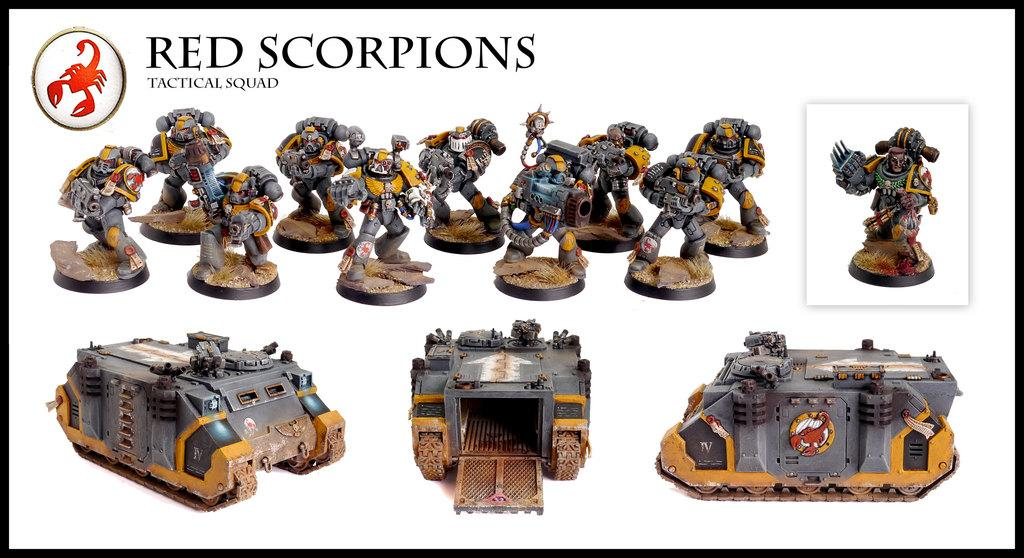What type of visual is the image? The image is a poster. What objects are shown on the poster? There are toys depicted on the poster. Where is the text located on the poster? The text is at the top of the poster. What color is the bead hanging from the curtain in the image? There is no bead or curtain present in the image; it is a poster featuring toys and text. 